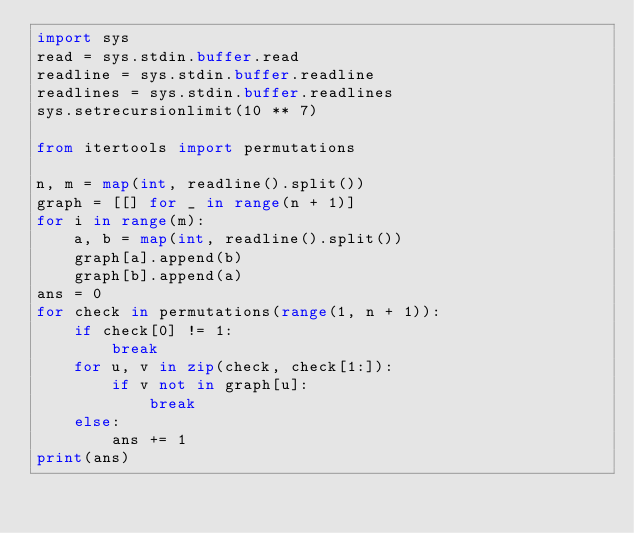<code> <loc_0><loc_0><loc_500><loc_500><_Python_>import sys
read = sys.stdin.buffer.read
readline = sys.stdin.buffer.readline
readlines = sys.stdin.buffer.readlines
sys.setrecursionlimit(10 ** 7)

from itertools import permutations

n, m = map(int, readline().split())
graph = [[] for _ in range(n + 1)]
for i in range(m):
    a, b = map(int, readline().split())
    graph[a].append(b)
    graph[b].append(a)
ans = 0
for check in permutations(range(1, n + 1)):
    if check[0] != 1:
        break
    for u, v in zip(check, check[1:]):
        if v not in graph[u]:
            break
    else:
        ans += 1
print(ans)
</code> 